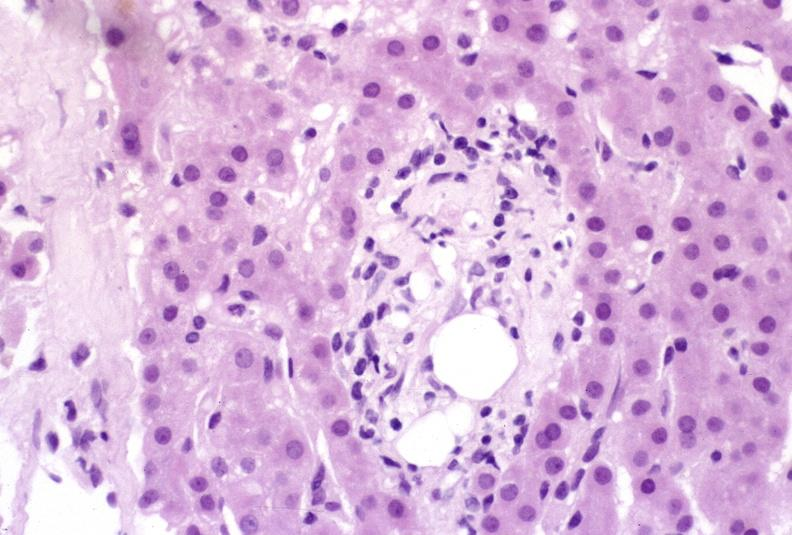s hepatobiliary present?
Answer the question using a single word or phrase. Yes 